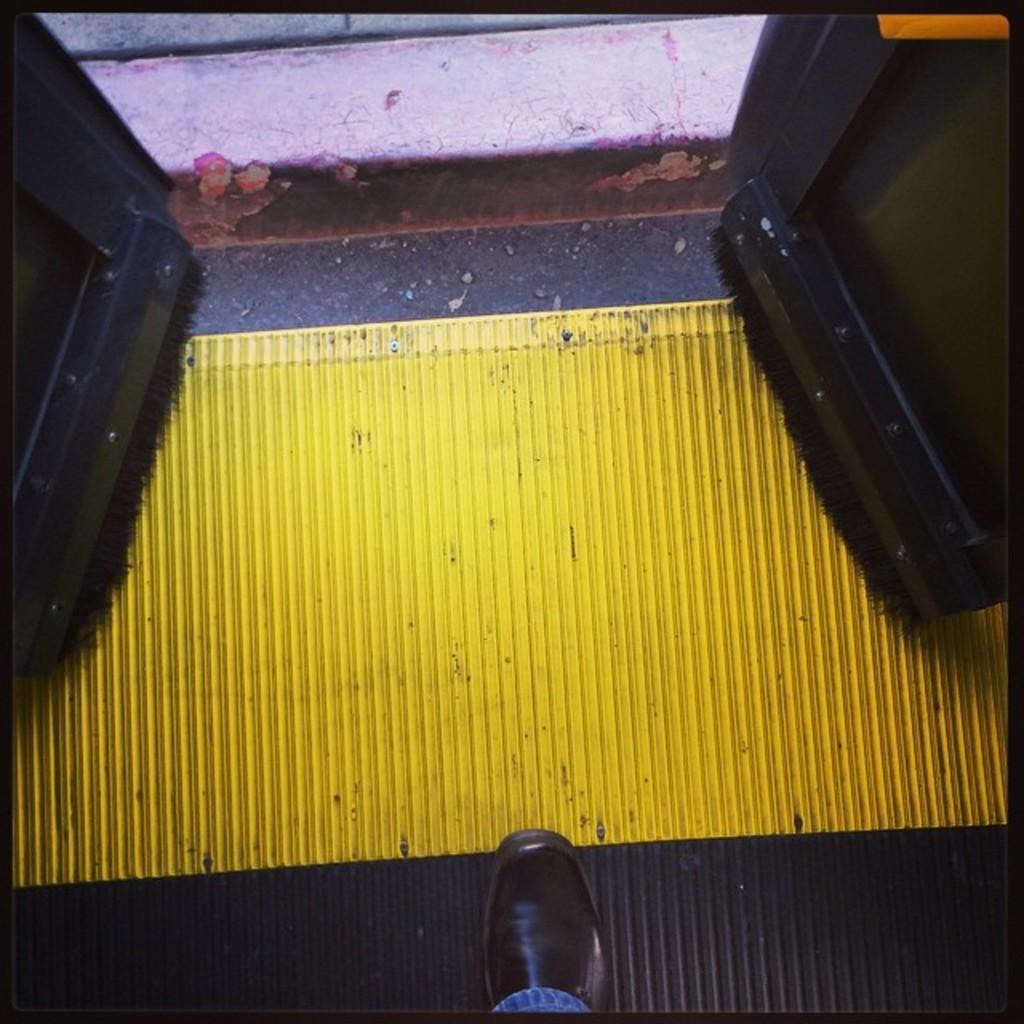Could you give a brief overview of what you see in this image? On the bottom we can see a person's leg who is wearing shoe and jeans. He is standing near to the doors. Here we can see a yellow color object. 